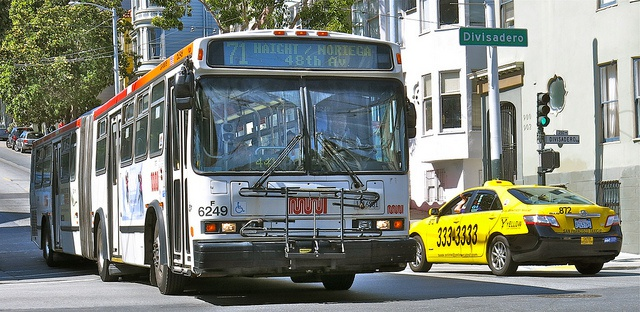Describe the objects in this image and their specific colors. I can see bus in darkgreen, black, gray, white, and darkgray tones, car in darkgreen, black, yellow, gray, and olive tones, people in darkgreen, gray, and blue tones, traffic light in darkgreen, black, gray, darkgray, and white tones, and car in darkgreen, gray, black, darkgray, and lightgray tones in this image. 